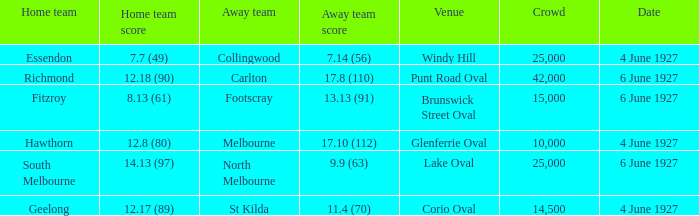How many people in the crowd with north melbourne as an away team? 25000.0. 